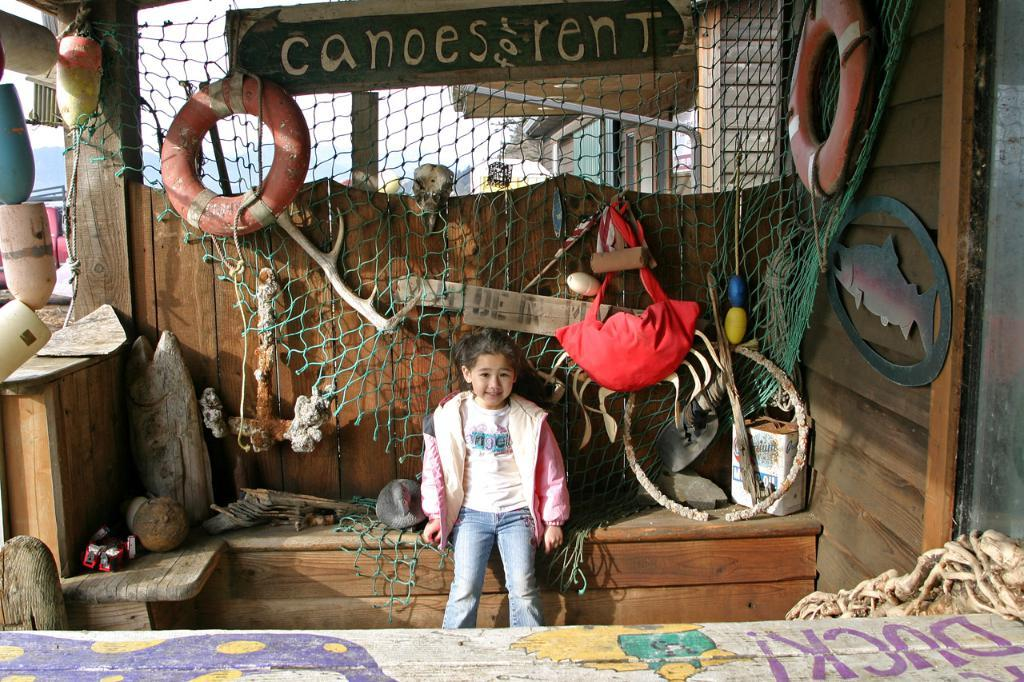What is the girl doing in the image? There is a girl seated in the image, but her activity is not specified. What object in the image is typically used for catching or holding things? There is a net in the image, which is commonly used for catching or holding things. What object in the image is long and hollow? There is a tube in the image, which is long and hollow. What object in the image is used for carrying or storing items? There is a bag in the image, which is used for carrying or storing items. What type of channel can be seen in the image? There is no channel present in the image. How many dimes are visible on the girl's hand in the image? There is no mention of dimes in the image, so it cannot be determined. What object in the image is typically used for pounding or breaking things? There is no hammer present in the image. 